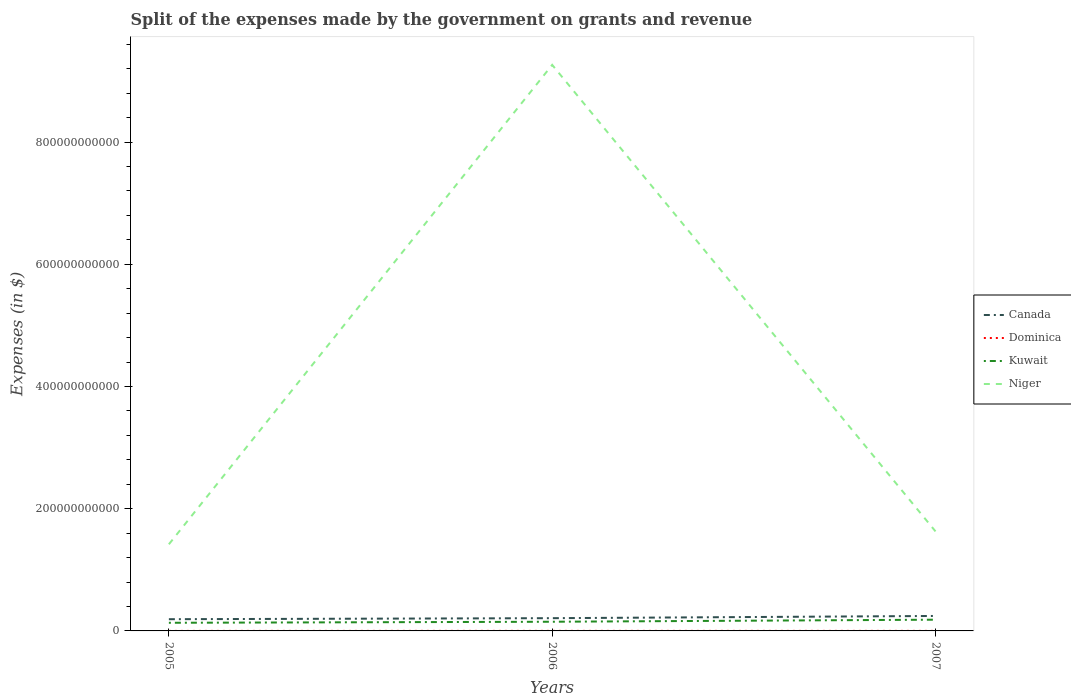How many different coloured lines are there?
Offer a terse response. 4. Across all years, what is the maximum expenses made by the government on grants and revenue in Kuwait?
Your answer should be compact. 1.33e+1. What is the total expenses made by the government on grants and revenue in Dominica in the graph?
Your answer should be compact. -5.02e+07. What is the difference between the highest and the second highest expenses made by the government on grants and revenue in Dominica?
Keep it short and to the point. 5.12e+07. How many years are there in the graph?
Give a very brief answer. 3. What is the difference between two consecutive major ticks on the Y-axis?
Provide a succinct answer. 2.00e+11. Does the graph contain any zero values?
Provide a succinct answer. No. How are the legend labels stacked?
Provide a succinct answer. Vertical. What is the title of the graph?
Provide a short and direct response. Split of the expenses made by the government on grants and revenue. Does "Kazakhstan" appear as one of the legend labels in the graph?
Your response must be concise. No. What is the label or title of the X-axis?
Provide a succinct answer. Years. What is the label or title of the Y-axis?
Provide a short and direct response. Expenses (in $). What is the Expenses (in $) in Canada in 2005?
Your answer should be compact. 1.92e+1. What is the Expenses (in $) in Dominica in 2005?
Keep it short and to the point. 3.38e+07. What is the Expenses (in $) in Kuwait in 2005?
Your answer should be very brief. 1.33e+1. What is the Expenses (in $) of Niger in 2005?
Your answer should be very brief. 1.42e+11. What is the Expenses (in $) in Canada in 2006?
Your response must be concise. 2.09e+1. What is the Expenses (in $) of Dominica in 2006?
Provide a succinct answer. 8.50e+07. What is the Expenses (in $) in Kuwait in 2006?
Offer a terse response. 1.50e+1. What is the Expenses (in $) of Niger in 2006?
Provide a short and direct response. 9.26e+11. What is the Expenses (in $) of Canada in 2007?
Provide a short and direct response. 2.45e+1. What is the Expenses (in $) of Dominica in 2007?
Keep it short and to the point. 8.40e+07. What is the Expenses (in $) in Kuwait in 2007?
Offer a very short reply. 1.84e+1. What is the Expenses (in $) in Niger in 2007?
Provide a short and direct response. 1.63e+11. Across all years, what is the maximum Expenses (in $) of Canada?
Offer a terse response. 2.45e+1. Across all years, what is the maximum Expenses (in $) in Dominica?
Give a very brief answer. 8.50e+07. Across all years, what is the maximum Expenses (in $) in Kuwait?
Your answer should be very brief. 1.84e+1. Across all years, what is the maximum Expenses (in $) of Niger?
Your response must be concise. 9.26e+11. Across all years, what is the minimum Expenses (in $) in Canada?
Provide a succinct answer. 1.92e+1. Across all years, what is the minimum Expenses (in $) in Dominica?
Your answer should be very brief. 3.38e+07. Across all years, what is the minimum Expenses (in $) in Kuwait?
Your response must be concise. 1.33e+1. Across all years, what is the minimum Expenses (in $) of Niger?
Your answer should be compact. 1.42e+11. What is the total Expenses (in $) of Canada in the graph?
Your response must be concise. 6.45e+1. What is the total Expenses (in $) in Dominica in the graph?
Ensure brevity in your answer.  2.03e+08. What is the total Expenses (in $) of Kuwait in the graph?
Make the answer very short. 4.67e+1. What is the total Expenses (in $) of Niger in the graph?
Give a very brief answer. 1.23e+12. What is the difference between the Expenses (in $) of Canada in 2005 and that in 2006?
Provide a succinct answer. -1.68e+09. What is the difference between the Expenses (in $) of Dominica in 2005 and that in 2006?
Offer a terse response. -5.12e+07. What is the difference between the Expenses (in $) of Kuwait in 2005 and that in 2006?
Keep it short and to the point. -1.70e+09. What is the difference between the Expenses (in $) in Niger in 2005 and that in 2006?
Ensure brevity in your answer.  -7.85e+11. What is the difference between the Expenses (in $) of Canada in 2005 and that in 2007?
Offer a very short reply. -5.30e+09. What is the difference between the Expenses (in $) of Dominica in 2005 and that in 2007?
Your answer should be compact. -5.02e+07. What is the difference between the Expenses (in $) in Kuwait in 2005 and that in 2007?
Offer a terse response. -5.08e+09. What is the difference between the Expenses (in $) of Niger in 2005 and that in 2007?
Your response must be concise. -2.11e+1. What is the difference between the Expenses (in $) in Canada in 2006 and that in 2007?
Your response must be concise. -3.62e+09. What is the difference between the Expenses (in $) of Kuwait in 2006 and that in 2007?
Your answer should be very brief. -3.38e+09. What is the difference between the Expenses (in $) of Niger in 2006 and that in 2007?
Offer a terse response. 7.63e+11. What is the difference between the Expenses (in $) of Canada in 2005 and the Expenses (in $) of Dominica in 2006?
Your response must be concise. 1.91e+1. What is the difference between the Expenses (in $) of Canada in 2005 and the Expenses (in $) of Kuwait in 2006?
Offer a very short reply. 4.16e+09. What is the difference between the Expenses (in $) in Canada in 2005 and the Expenses (in $) in Niger in 2006?
Keep it short and to the point. -9.07e+11. What is the difference between the Expenses (in $) in Dominica in 2005 and the Expenses (in $) in Kuwait in 2006?
Ensure brevity in your answer.  -1.50e+1. What is the difference between the Expenses (in $) in Dominica in 2005 and the Expenses (in $) in Niger in 2006?
Ensure brevity in your answer.  -9.26e+11. What is the difference between the Expenses (in $) in Kuwait in 2005 and the Expenses (in $) in Niger in 2006?
Offer a very short reply. -9.13e+11. What is the difference between the Expenses (in $) in Canada in 2005 and the Expenses (in $) in Dominica in 2007?
Your answer should be compact. 1.91e+1. What is the difference between the Expenses (in $) in Canada in 2005 and the Expenses (in $) in Kuwait in 2007?
Give a very brief answer. 7.88e+08. What is the difference between the Expenses (in $) in Canada in 2005 and the Expenses (in $) in Niger in 2007?
Your answer should be compact. -1.44e+11. What is the difference between the Expenses (in $) in Dominica in 2005 and the Expenses (in $) in Kuwait in 2007?
Keep it short and to the point. -1.84e+1. What is the difference between the Expenses (in $) of Dominica in 2005 and the Expenses (in $) of Niger in 2007?
Provide a succinct answer. -1.63e+11. What is the difference between the Expenses (in $) in Kuwait in 2005 and the Expenses (in $) in Niger in 2007?
Your answer should be compact. -1.50e+11. What is the difference between the Expenses (in $) of Canada in 2006 and the Expenses (in $) of Dominica in 2007?
Offer a very short reply. 2.08e+1. What is the difference between the Expenses (in $) in Canada in 2006 and the Expenses (in $) in Kuwait in 2007?
Give a very brief answer. 2.47e+09. What is the difference between the Expenses (in $) in Canada in 2006 and the Expenses (in $) in Niger in 2007?
Offer a terse response. -1.42e+11. What is the difference between the Expenses (in $) in Dominica in 2006 and the Expenses (in $) in Kuwait in 2007?
Provide a short and direct response. -1.83e+1. What is the difference between the Expenses (in $) of Dominica in 2006 and the Expenses (in $) of Niger in 2007?
Your response must be concise. -1.63e+11. What is the difference between the Expenses (in $) of Kuwait in 2006 and the Expenses (in $) of Niger in 2007?
Ensure brevity in your answer.  -1.48e+11. What is the average Expenses (in $) of Canada per year?
Give a very brief answer. 2.15e+1. What is the average Expenses (in $) in Dominica per year?
Your response must be concise. 6.76e+07. What is the average Expenses (in $) of Kuwait per year?
Give a very brief answer. 1.56e+1. What is the average Expenses (in $) in Niger per year?
Your answer should be compact. 4.10e+11. In the year 2005, what is the difference between the Expenses (in $) of Canada and Expenses (in $) of Dominica?
Ensure brevity in your answer.  1.91e+1. In the year 2005, what is the difference between the Expenses (in $) of Canada and Expenses (in $) of Kuwait?
Make the answer very short. 5.87e+09. In the year 2005, what is the difference between the Expenses (in $) of Canada and Expenses (in $) of Niger?
Provide a succinct answer. -1.23e+11. In the year 2005, what is the difference between the Expenses (in $) of Dominica and Expenses (in $) of Kuwait?
Your response must be concise. -1.33e+1. In the year 2005, what is the difference between the Expenses (in $) in Dominica and Expenses (in $) in Niger?
Your answer should be very brief. -1.42e+11. In the year 2005, what is the difference between the Expenses (in $) of Kuwait and Expenses (in $) of Niger?
Provide a short and direct response. -1.28e+11. In the year 2006, what is the difference between the Expenses (in $) in Canada and Expenses (in $) in Dominica?
Your answer should be very brief. 2.08e+1. In the year 2006, what is the difference between the Expenses (in $) in Canada and Expenses (in $) in Kuwait?
Your response must be concise. 5.84e+09. In the year 2006, what is the difference between the Expenses (in $) of Canada and Expenses (in $) of Niger?
Provide a short and direct response. -9.05e+11. In the year 2006, what is the difference between the Expenses (in $) in Dominica and Expenses (in $) in Kuwait?
Your answer should be compact. -1.49e+1. In the year 2006, what is the difference between the Expenses (in $) in Dominica and Expenses (in $) in Niger?
Give a very brief answer. -9.26e+11. In the year 2006, what is the difference between the Expenses (in $) of Kuwait and Expenses (in $) of Niger?
Keep it short and to the point. -9.11e+11. In the year 2007, what is the difference between the Expenses (in $) of Canada and Expenses (in $) of Dominica?
Offer a terse response. 2.44e+1. In the year 2007, what is the difference between the Expenses (in $) in Canada and Expenses (in $) in Kuwait?
Your answer should be compact. 6.09e+09. In the year 2007, what is the difference between the Expenses (in $) of Canada and Expenses (in $) of Niger?
Provide a succinct answer. -1.38e+11. In the year 2007, what is the difference between the Expenses (in $) in Dominica and Expenses (in $) in Kuwait?
Provide a succinct answer. -1.83e+1. In the year 2007, what is the difference between the Expenses (in $) of Dominica and Expenses (in $) of Niger?
Offer a very short reply. -1.63e+11. In the year 2007, what is the difference between the Expenses (in $) of Kuwait and Expenses (in $) of Niger?
Offer a very short reply. -1.44e+11. What is the ratio of the Expenses (in $) of Canada in 2005 to that in 2006?
Offer a very short reply. 0.92. What is the ratio of the Expenses (in $) in Dominica in 2005 to that in 2006?
Your response must be concise. 0.4. What is the ratio of the Expenses (in $) in Kuwait in 2005 to that in 2006?
Keep it short and to the point. 0.89. What is the ratio of the Expenses (in $) of Niger in 2005 to that in 2006?
Offer a very short reply. 0.15. What is the ratio of the Expenses (in $) in Canada in 2005 to that in 2007?
Your response must be concise. 0.78. What is the ratio of the Expenses (in $) of Dominica in 2005 to that in 2007?
Your response must be concise. 0.4. What is the ratio of the Expenses (in $) of Kuwait in 2005 to that in 2007?
Give a very brief answer. 0.72. What is the ratio of the Expenses (in $) in Niger in 2005 to that in 2007?
Keep it short and to the point. 0.87. What is the ratio of the Expenses (in $) in Canada in 2006 to that in 2007?
Ensure brevity in your answer.  0.85. What is the ratio of the Expenses (in $) in Dominica in 2006 to that in 2007?
Ensure brevity in your answer.  1.01. What is the ratio of the Expenses (in $) of Kuwait in 2006 to that in 2007?
Offer a very short reply. 0.82. What is the ratio of the Expenses (in $) in Niger in 2006 to that in 2007?
Offer a very short reply. 5.69. What is the difference between the highest and the second highest Expenses (in $) in Canada?
Keep it short and to the point. 3.62e+09. What is the difference between the highest and the second highest Expenses (in $) of Kuwait?
Give a very brief answer. 3.38e+09. What is the difference between the highest and the second highest Expenses (in $) in Niger?
Your answer should be compact. 7.63e+11. What is the difference between the highest and the lowest Expenses (in $) of Canada?
Give a very brief answer. 5.30e+09. What is the difference between the highest and the lowest Expenses (in $) of Dominica?
Keep it short and to the point. 5.12e+07. What is the difference between the highest and the lowest Expenses (in $) in Kuwait?
Offer a very short reply. 5.08e+09. What is the difference between the highest and the lowest Expenses (in $) of Niger?
Keep it short and to the point. 7.85e+11. 